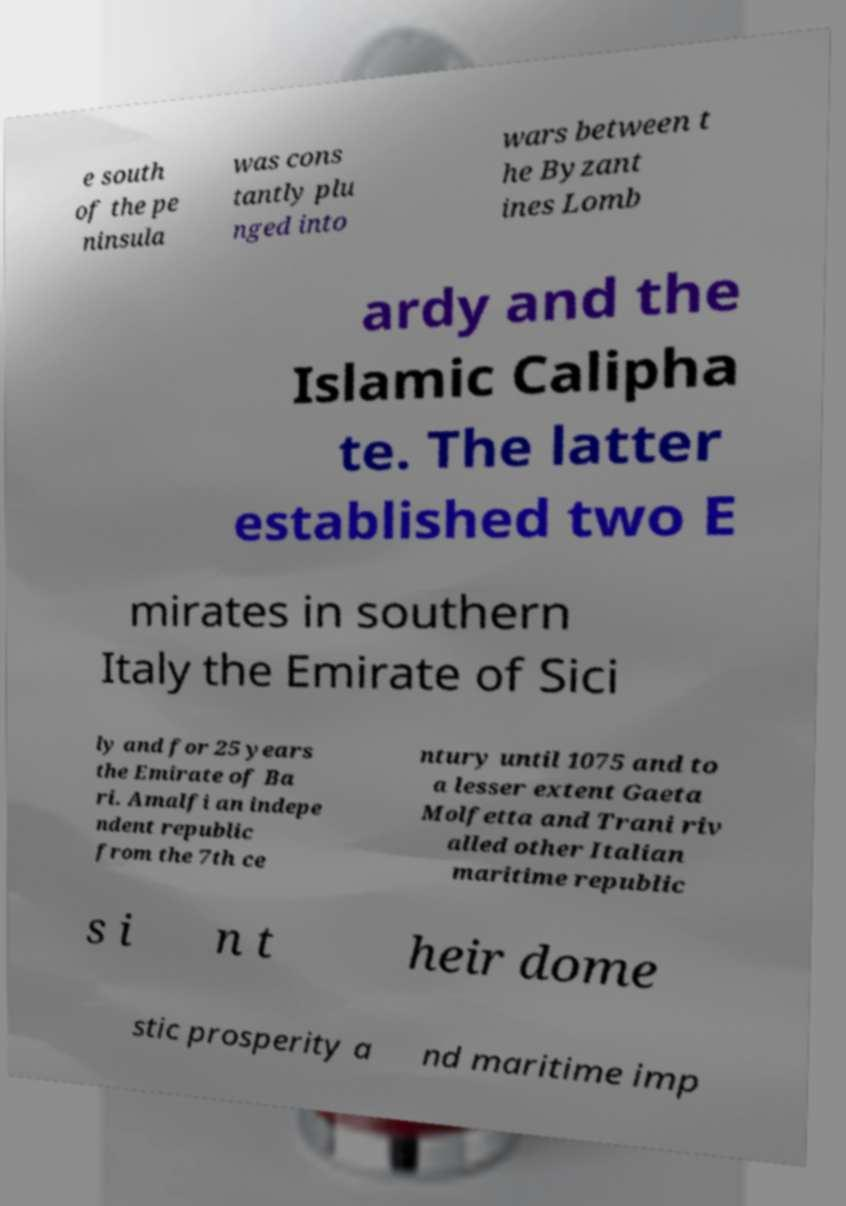There's text embedded in this image that I need extracted. Can you transcribe it verbatim? e south of the pe ninsula was cons tantly plu nged into wars between t he Byzant ines Lomb ardy and the Islamic Calipha te. The latter established two E mirates in southern Italy the Emirate of Sici ly and for 25 years the Emirate of Ba ri. Amalfi an indepe ndent republic from the 7th ce ntury until 1075 and to a lesser extent Gaeta Molfetta and Trani riv alled other Italian maritime republic s i n t heir dome stic prosperity a nd maritime imp 